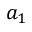<formula> <loc_0><loc_0><loc_500><loc_500>a _ { 1 }</formula> 